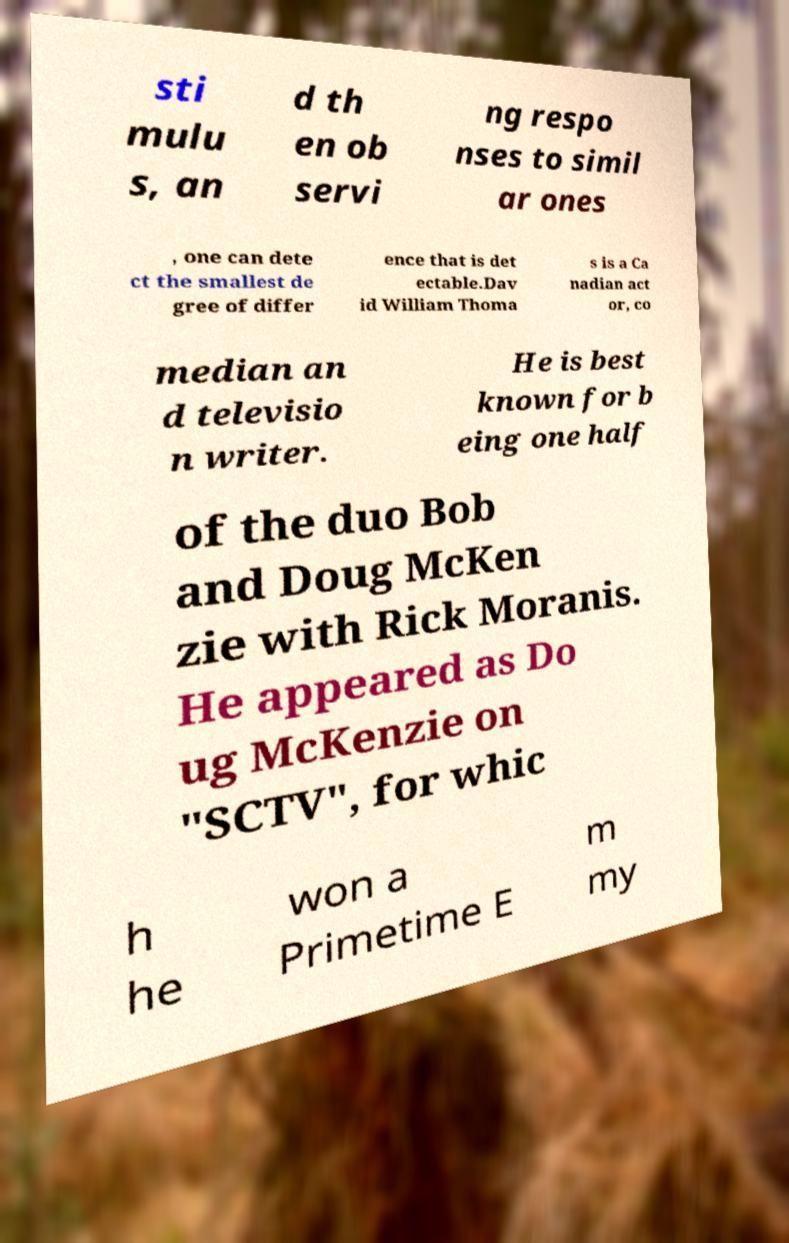Please read and relay the text visible in this image. What does it say? sti mulu s, an d th en ob servi ng respo nses to simil ar ones , one can dete ct the smallest de gree of differ ence that is det ectable.Dav id William Thoma s is a Ca nadian act or, co median an d televisio n writer. He is best known for b eing one half of the duo Bob and Doug McKen zie with Rick Moranis. He appeared as Do ug McKenzie on "SCTV", for whic h he won a Primetime E m my 